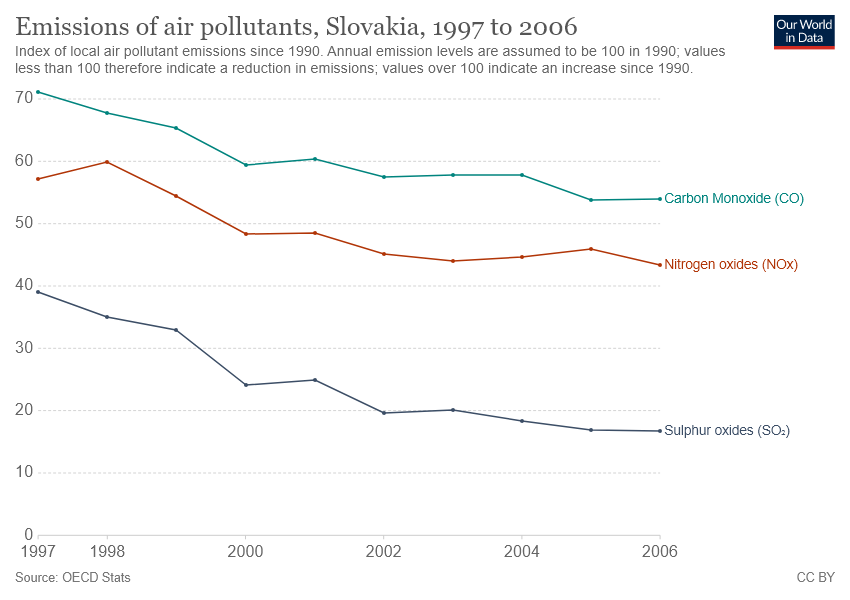Give some essential details in this illustration. The air pollutant represented by the red line is nitrogen oxides (NOx). The difference in sulfur oxide emissions between the year 1997 and 2003 is approximately X. 